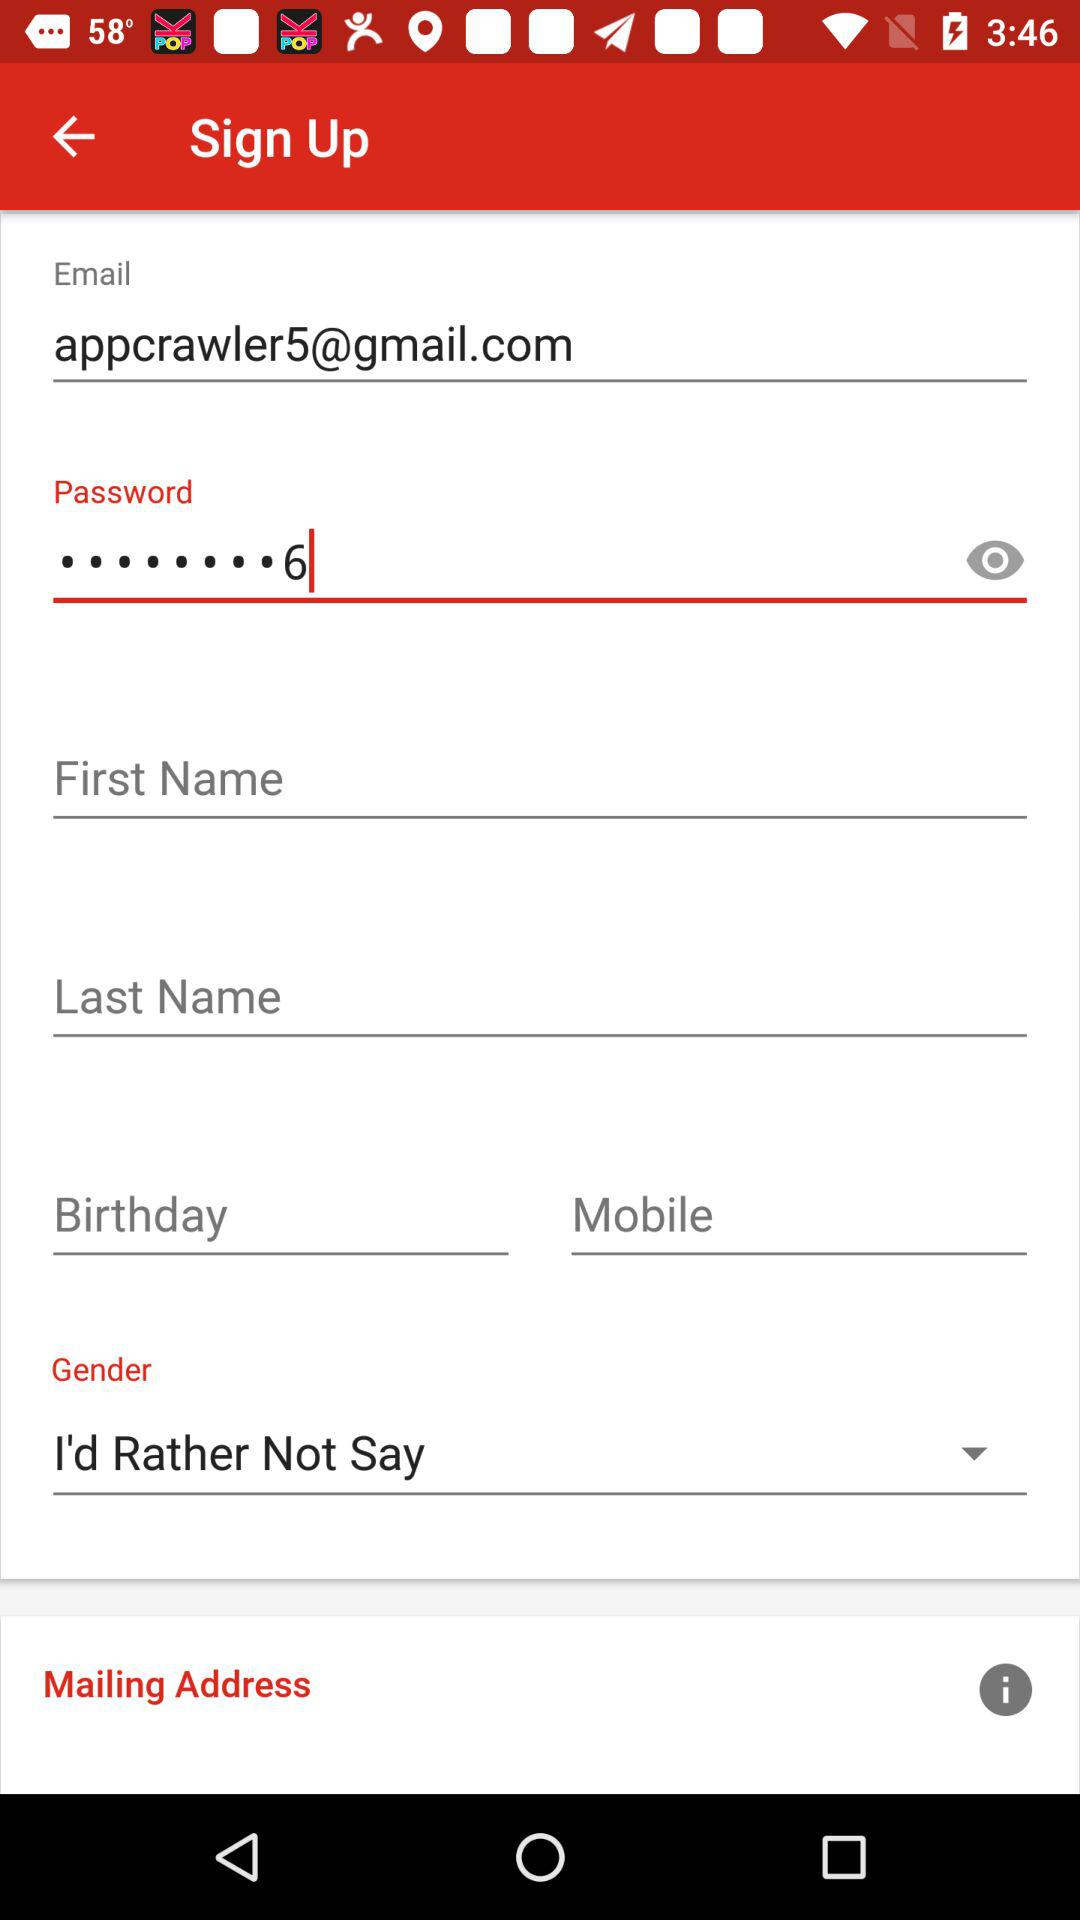What is the email address? The email address is "appcrawler5@gmail.com". 